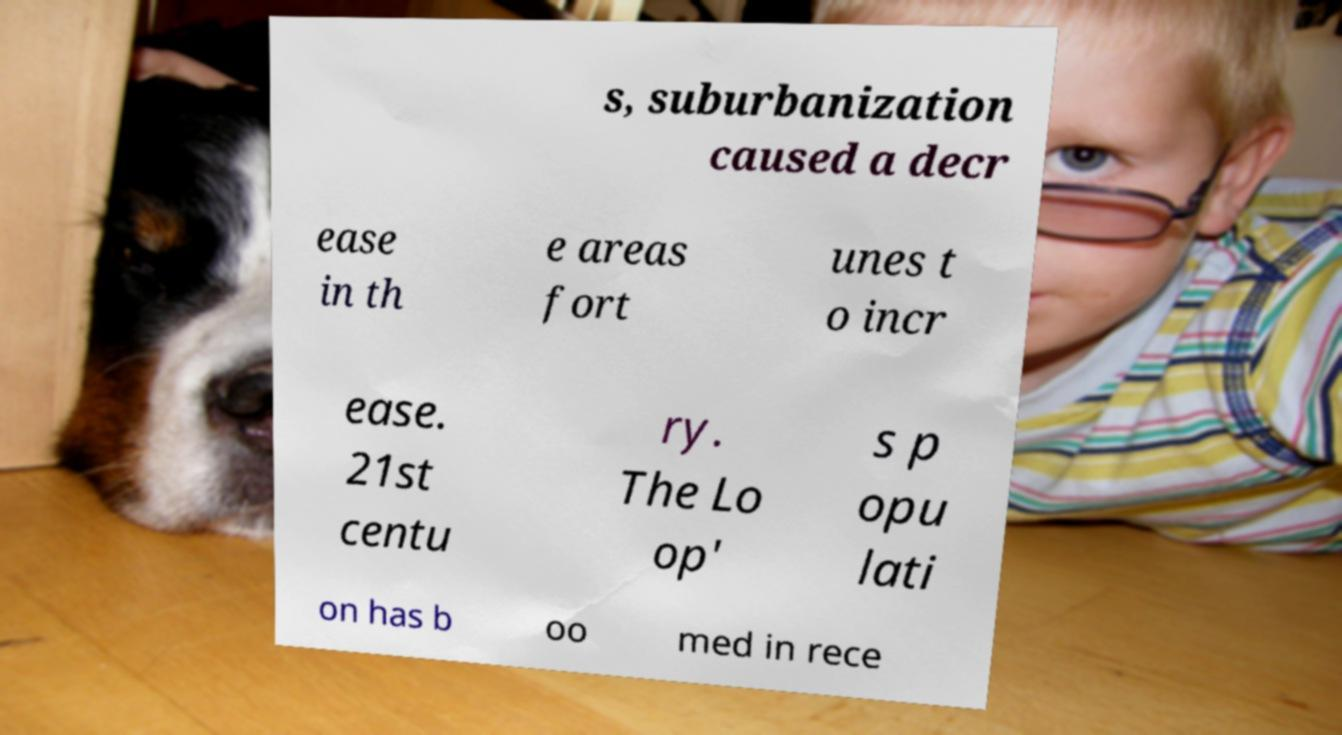For documentation purposes, I need the text within this image transcribed. Could you provide that? s, suburbanization caused a decr ease in th e areas fort unes t o incr ease. 21st centu ry. The Lo op' s p opu lati on has b oo med in rece 